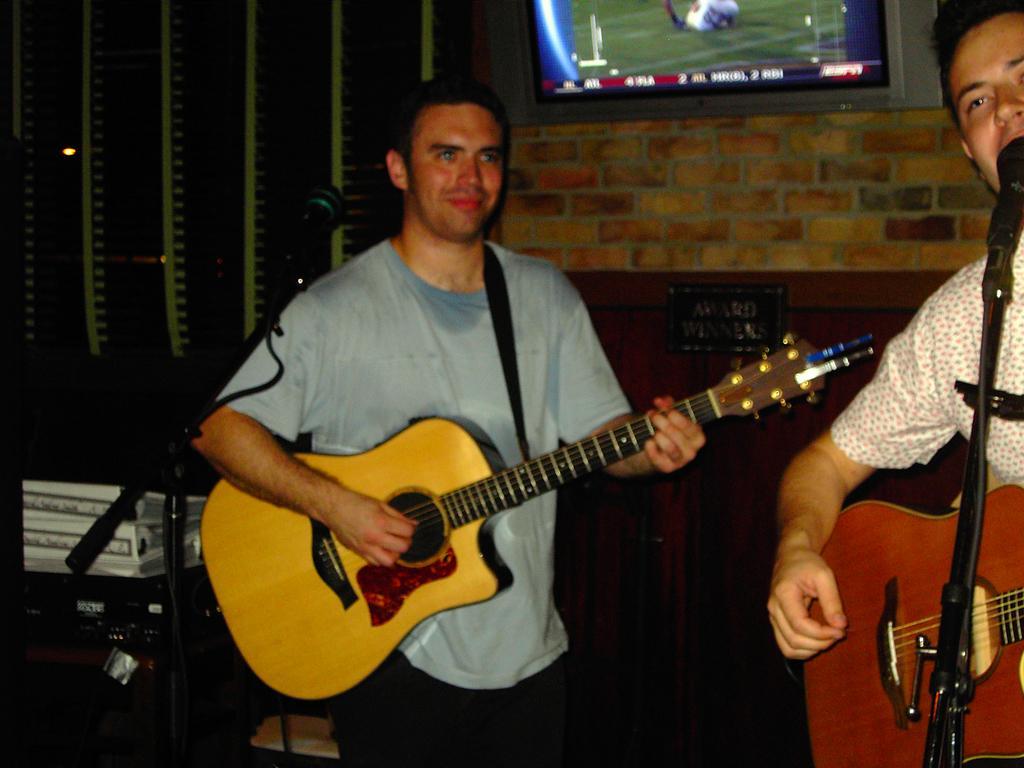In one or two sentences, can you explain what this image depicts? In this image there are two persons performing. At the right side the man is holding a guitar in his hand and is singing in front of the mic. In the center the man is holding a guitar in his hand and is having smile on his face. In the background there is a TV running and a wall. 